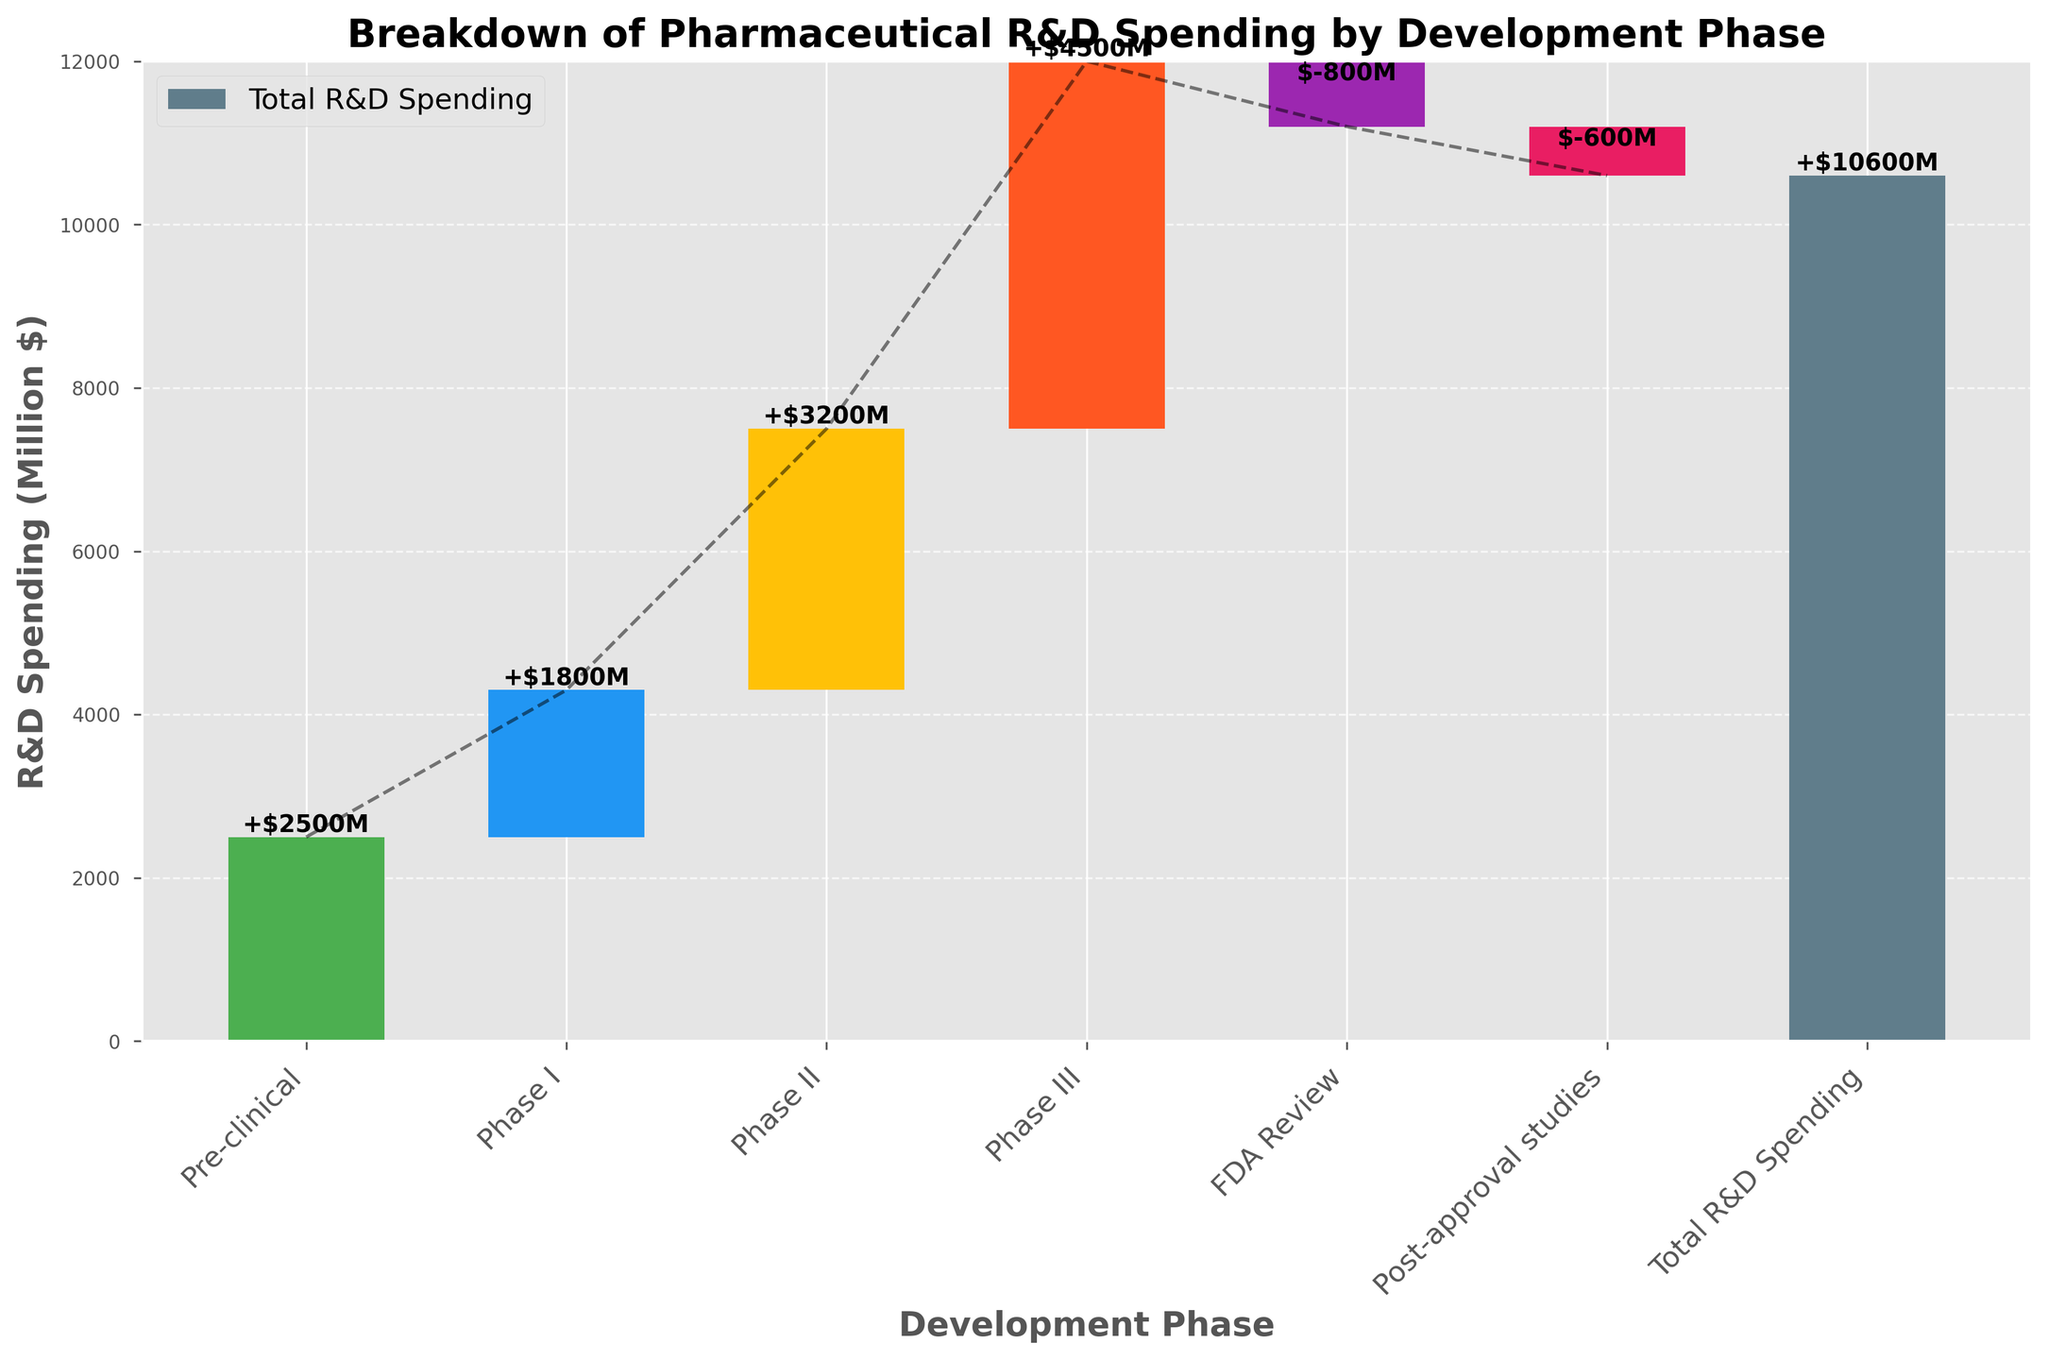What's the title of the figure? The title of the figure is located at the top and serves as a summary of what the chart represents. Looking at the top of the graph will reveal this information.
Answer: Breakdown of Pharmaceutical R&D Spending by Development Phase How much is spent on Phase II of drug development? Identify the bar corresponding to 'Phase II' in the chart and note the value labeled on it.
Answer: 3200 What color represents spending on Pre-clinical development? Trace the bar labeled 'Pre-clinical' and identify its color, which visually represents this category.
Answer: Green What's the total R&D spending amount in the chart? The total R&D spending is given as the last category in the chart and includes a separate bar labeled 'Total R&D Spending'.
Answer: 10600 Which phase has the highest spending, and how much is it? Compare the lengths of the bars representing each development phase and identify the longest one. The value on this bar gives the highest spending.
Answer: Phase III, 4500 What is the difference in spending between Phase I and Phase III? Subtract the value of spending in Phase I from the value of spending in Phase III (4500 - 1800).
Answer: 2700 What is the least amount of money spent in any phase, and which phase does it correspond to? Look for the shortest or most negative bar among the categories. Identify the value and its corresponding phase.
Answer: FDA Review, -800 What are the total expenditures spent during clinical phases (Phase I, II, and III)? Sum the spending values for Phase I, II, and III (1800 + 3200 + 4500).
Answer: 9500 What is the cumulative spending after Phase II? Sum up the expenditures on Pre-clinical, Phase I, and Phase II (2500 + 1800 + 3200).
Answer: 7500 Why is there a negative value in FDA Review and Post-approval studies? The negative values in FDA Review and Post-approval studies represent reduced spending in those phases to account for savings or less resource utilization compared to other phases.
Answer: Reduced spending 